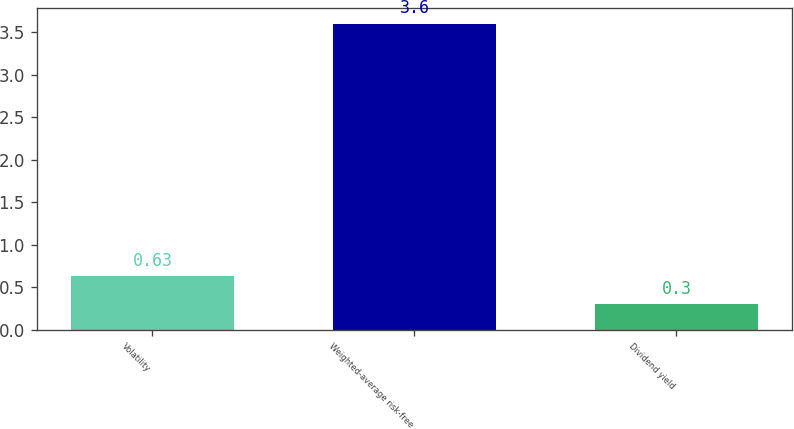Convert chart. <chart><loc_0><loc_0><loc_500><loc_500><bar_chart><fcel>Volatility<fcel>Weighted-average risk-free<fcel>Dividend yield<nl><fcel>0.63<fcel>3.6<fcel>0.3<nl></chart> 